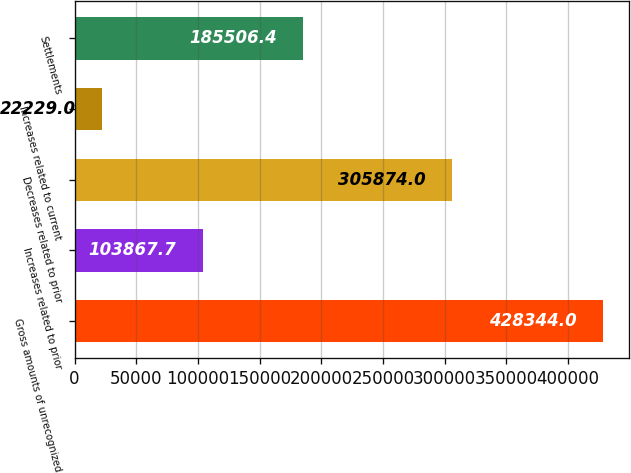<chart> <loc_0><loc_0><loc_500><loc_500><bar_chart><fcel>Gross amounts of unrecognized<fcel>Increases related to prior<fcel>Decreases related to prior<fcel>Increases related to current<fcel>Settlements<nl><fcel>428344<fcel>103868<fcel>305874<fcel>22229<fcel>185506<nl></chart> 